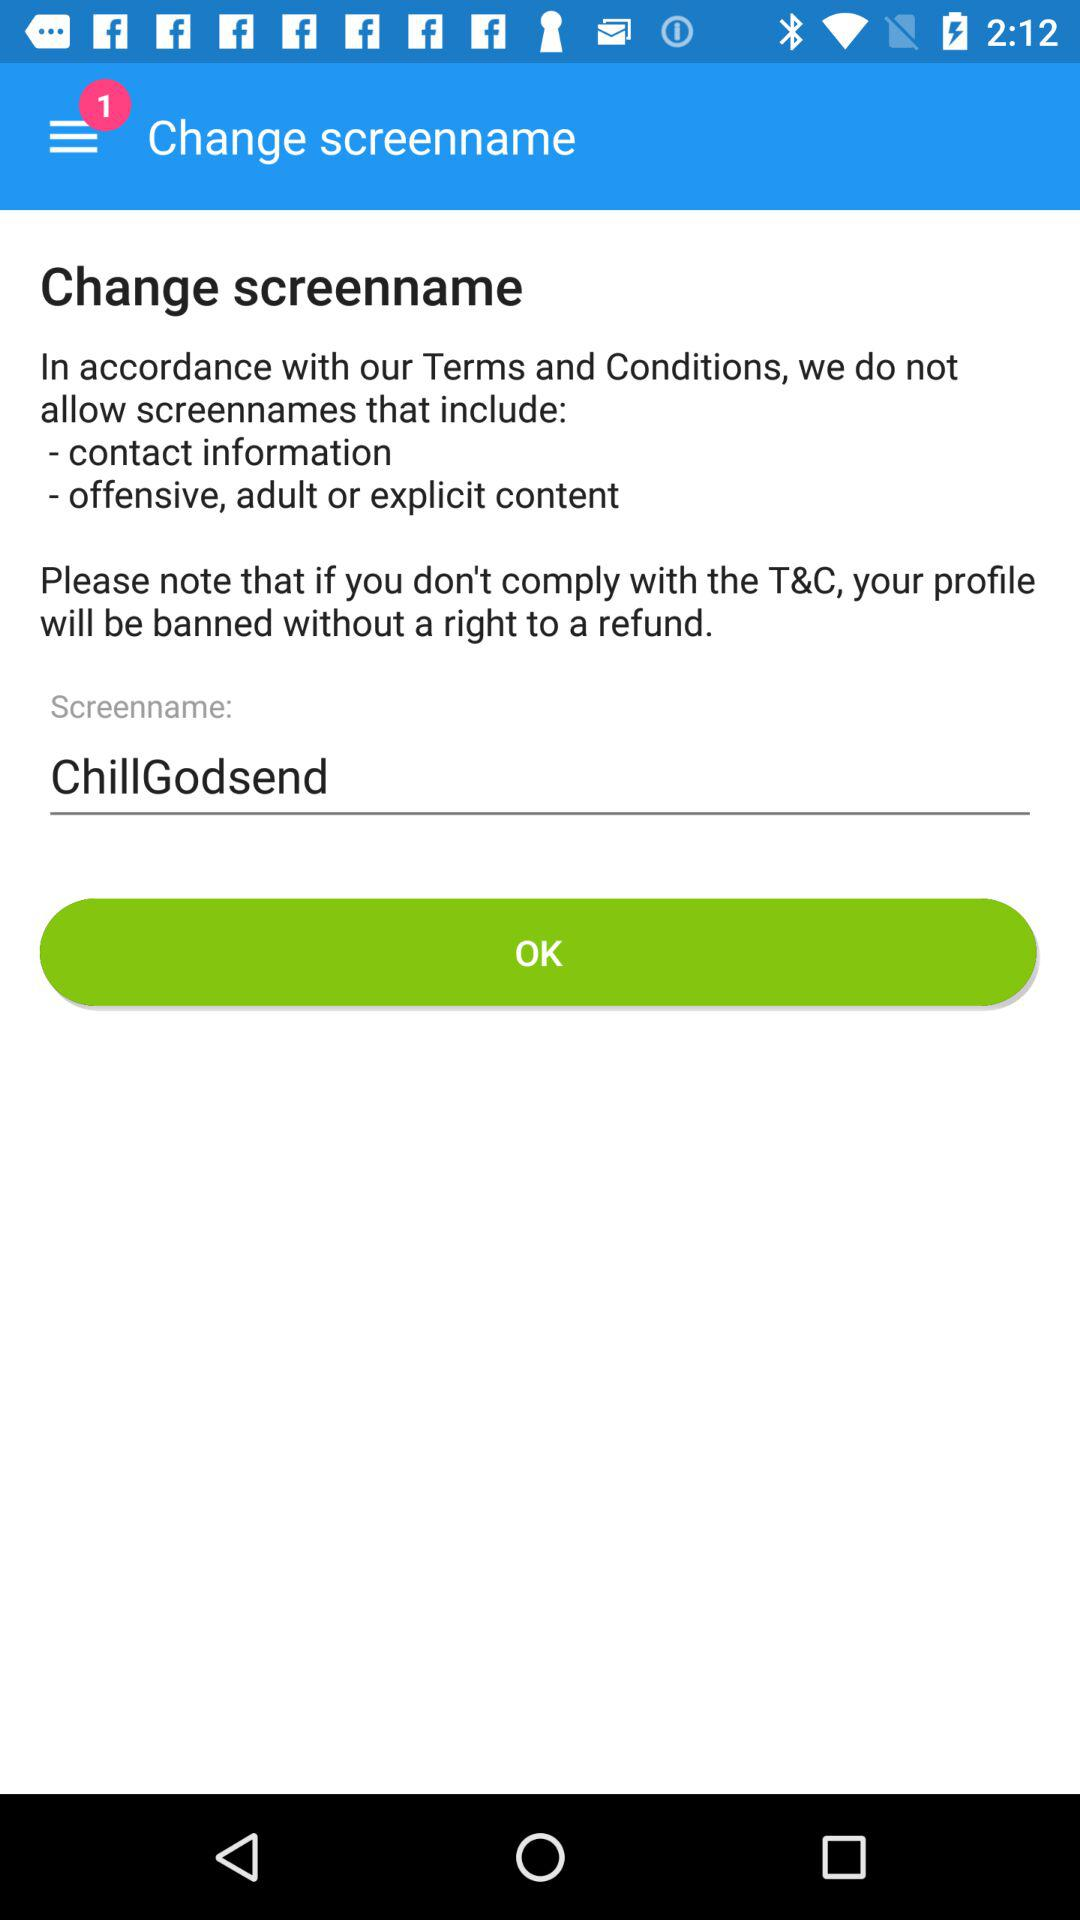What is the screenname? The screenname is "ChillGodsend". 